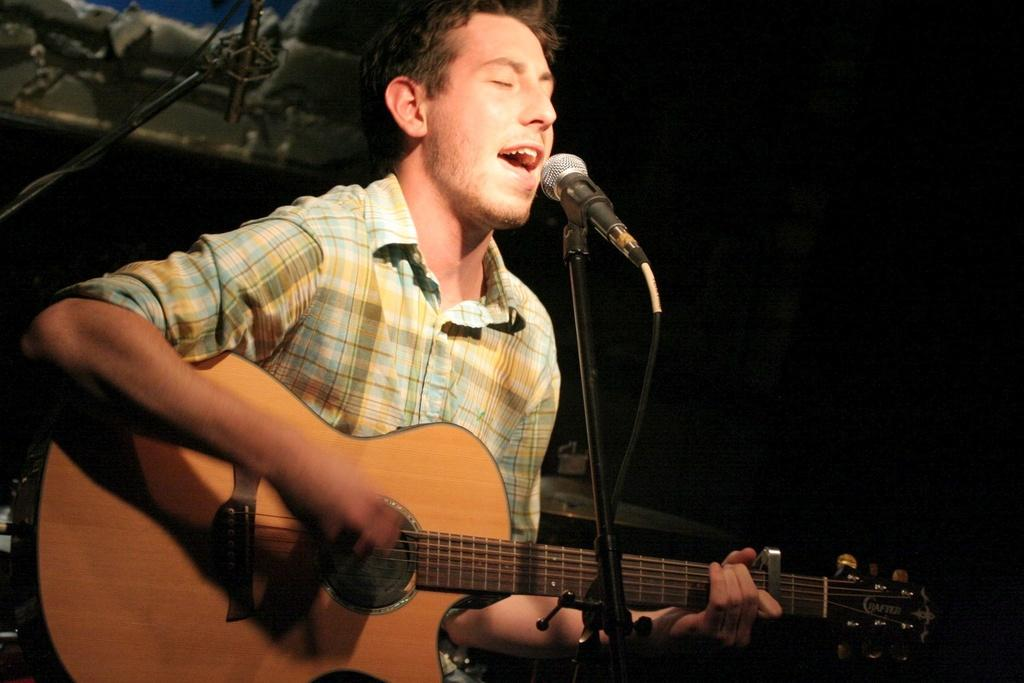What is the man in the image doing? The man is holding a music instrument and singing into a microphone. What can be seen in the man's hands? The man is holding a music instrument. What color is the wall in the background of the image? The wall in the background of the image is black. What type of fang can be seen in the man's mouth while he sings? There is no fang visible in the man's mouth while he sings; he is simply holding a music instrument and singing into a microphone. 